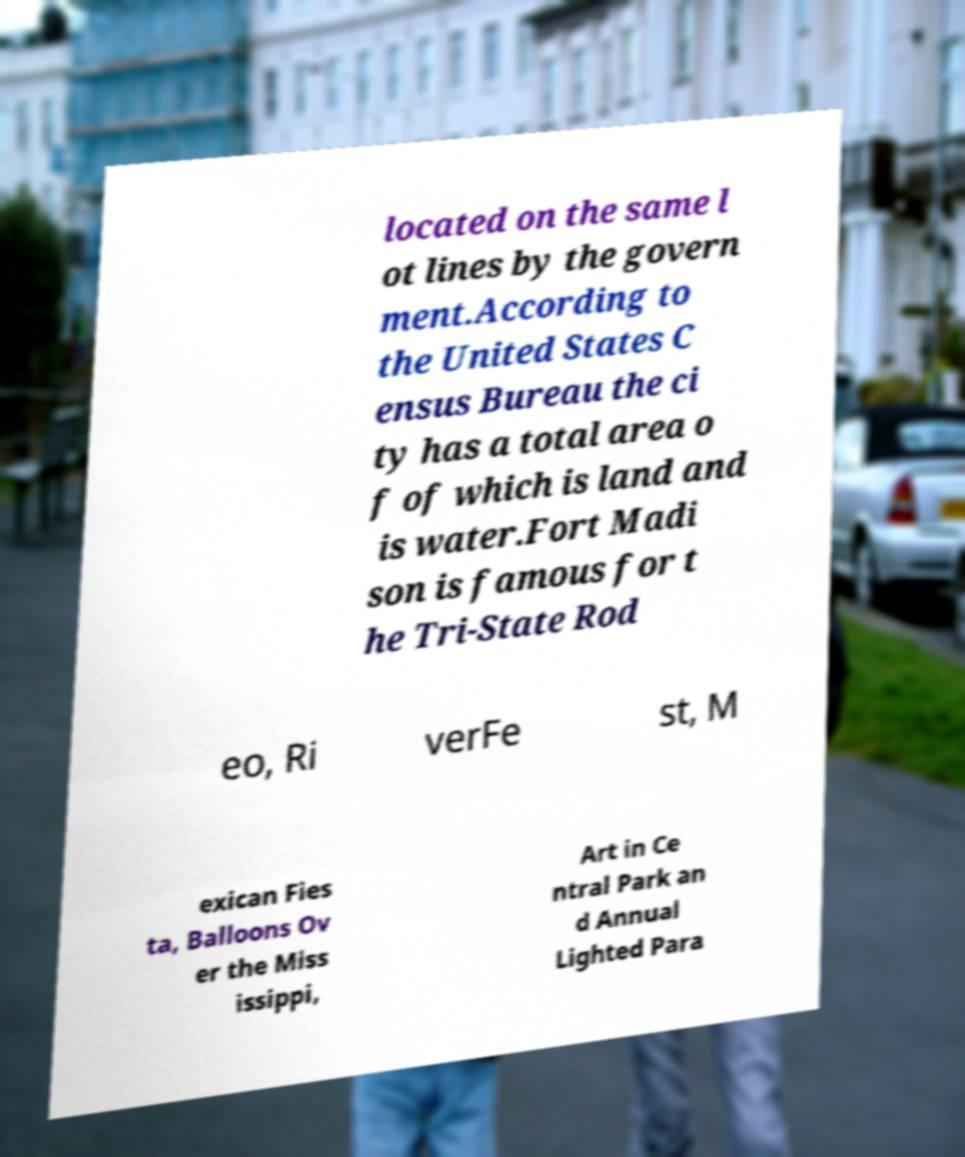What messages or text are displayed in this image? I need them in a readable, typed format. located on the same l ot lines by the govern ment.According to the United States C ensus Bureau the ci ty has a total area o f of which is land and is water.Fort Madi son is famous for t he Tri-State Rod eo, Ri verFe st, M exican Fies ta, Balloons Ov er the Miss issippi, Art in Ce ntral Park an d Annual Lighted Para 